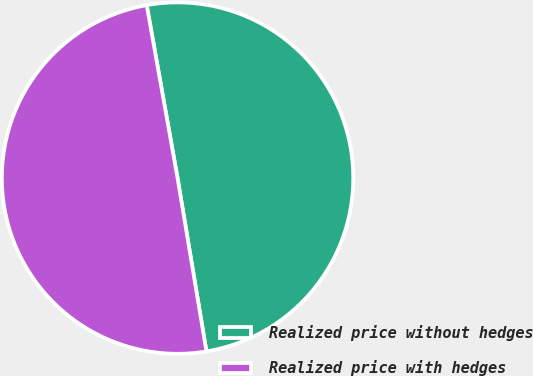<chart> <loc_0><loc_0><loc_500><loc_500><pie_chart><fcel>Realized price without hedges<fcel>Realized price with hedges<nl><fcel>50.18%<fcel>49.82%<nl></chart> 